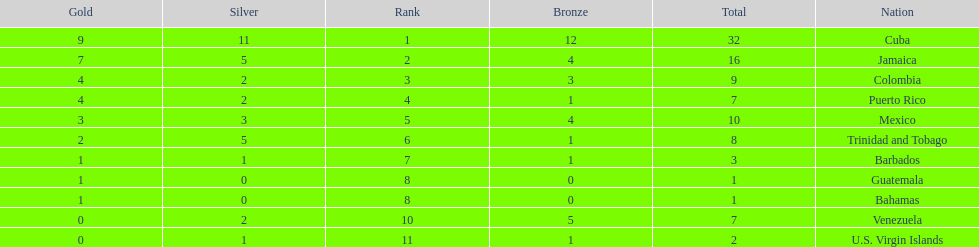Nations that had 10 or more medals each Cuba, Jamaica, Mexico. 